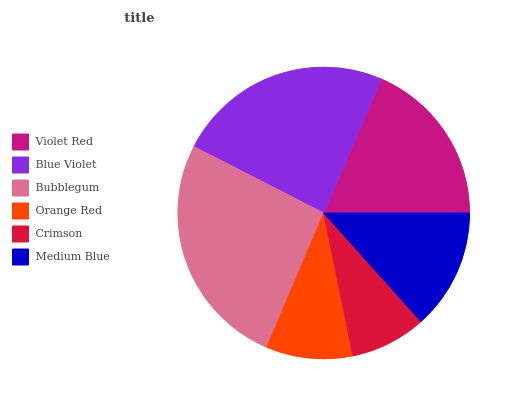Is Crimson the minimum?
Answer yes or no. Yes. Is Bubblegum the maximum?
Answer yes or no. Yes. Is Blue Violet the minimum?
Answer yes or no. No. Is Blue Violet the maximum?
Answer yes or no. No. Is Blue Violet greater than Violet Red?
Answer yes or no. Yes. Is Violet Red less than Blue Violet?
Answer yes or no. Yes. Is Violet Red greater than Blue Violet?
Answer yes or no. No. Is Blue Violet less than Violet Red?
Answer yes or no. No. Is Violet Red the high median?
Answer yes or no. Yes. Is Medium Blue the low median?
Answer yes or no. Yes. Is Bubblegum the high median?
Answer yes or no. No. Is Blue Violet the low median?
Answer yes or no. No. 